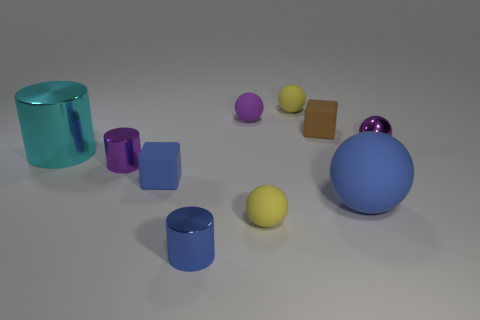Subtract all blue spheres. How many spheres are left? 4 Subtract all purple balls. How many balls are left? 3 Subtract 1 cylinders. How many cylinders are left? 2 Subtract all gray balls. How many brown cubes are left? 1 Subtract all gray rubber objects. Subtract all metal objects. How many objects are left? 6 Add 5 tiny blue metallic objects. How many tiny blue metallic objects are left? 6 Add 6 tiny shiny things. How many tiny shiny things exist? 9 Subtract 1 blue cylinders. How many objects are left? 9 Subtract all cubes. How many objects are left? 8 Subtract all brown balls. Subtract all brown cubes. How many balls are left? 5 